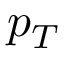<formula> <loc_0><loc_0><loc_500><loc_500>p _ { T }</formula> 